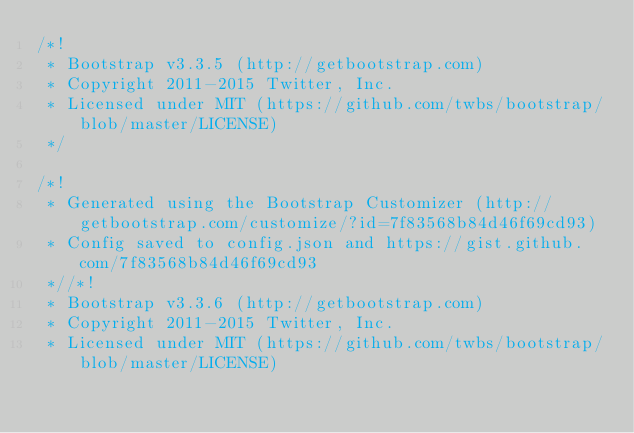<code> <loc_0><loc_0><loc_500><loc_500><_CSS_>/*!
 * Bootstrap v3.3.5 (http://getbootstrap.com)
 * Copyright 2011-2015 Twitter, Inc.
 * Licensed under MIT (https://github.com/twbs/bootstrap/blob/master/LICENSE)
 */

/*!
 * Generated using the Bootstrap Customizer (http://getbootstrap.com/customize/?id=7f83568b84d46f69cd93)
 * Config saved to config.json and https://gist.github.com/7f83568b84d46f69cd93
 *//*!
 * Bootstrap v3.3.6 (http://getbootstrap.com)
 * Copyright 2011-2015 Twitter, Inc.
 * Licensed under MIT (https://github.com/twbs/bootstrap/blob/master/LICENSE)</code> 